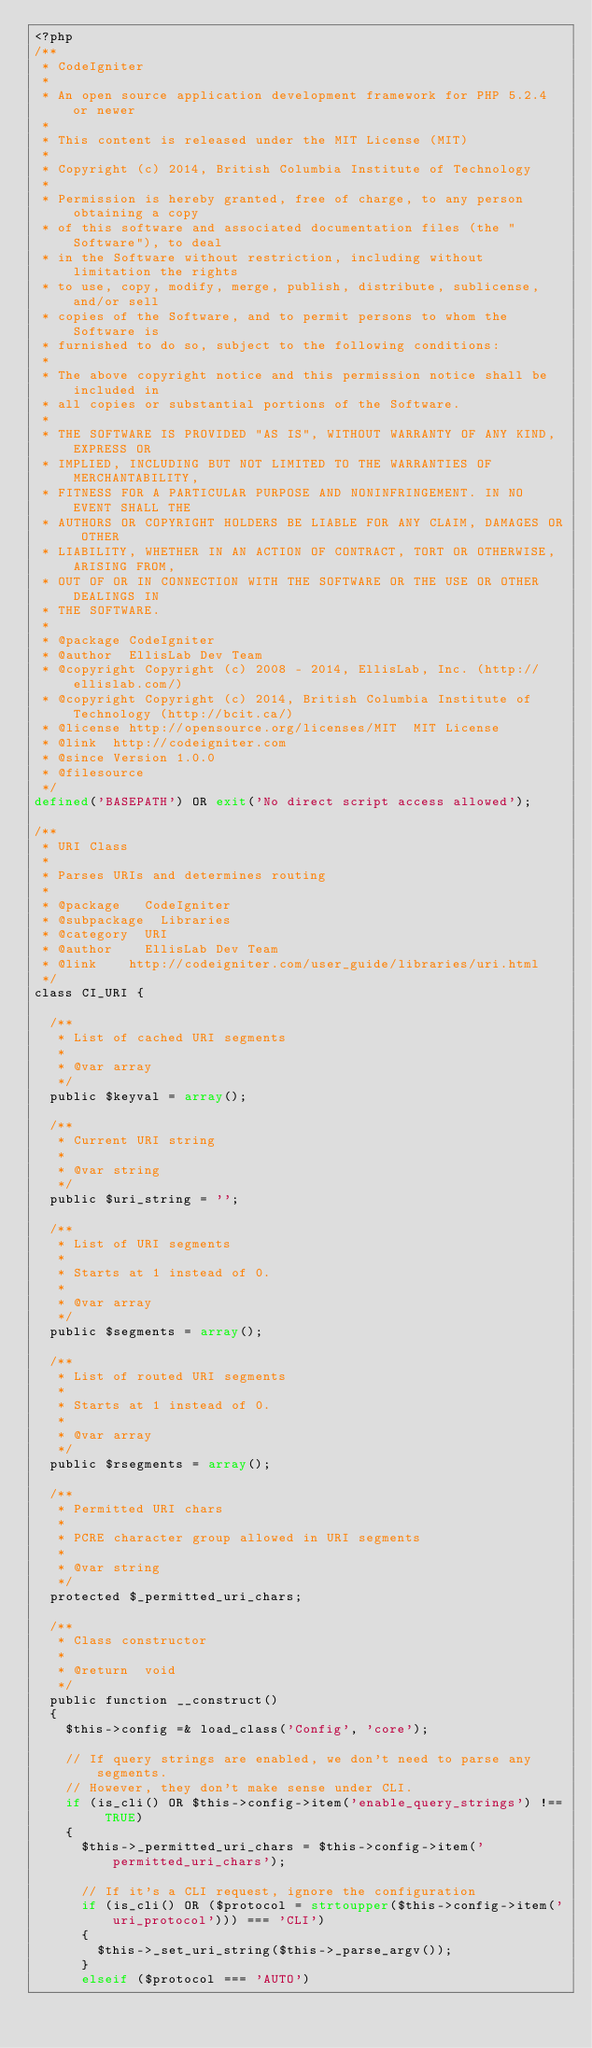<code> <loc_0><loc_0><loc_500><loc_500><_PHP_><?php
/**
 * CodeIgniter
 *
 * An open source application development framework for PHP 5.2.4 or newer
 *
 * This content is released under the MIT License (MIT)
 *
 * Copyright (c) 2014, British Columbia Institute of Technology
 *
 * Permission is hereby granted, free of charge, to any person obtaining a copy
 * of this software and associated documentation files (the "Software"), to deal
 * in the Software without restriction, including without limitation the rights
 * to use, copy, modify, merge, publish, distribute, sublicense, and/or sell
 * copies of the Software, and to permit persons to whom the Software is
 * furnished to do so, subject to the following conditions:
 *
 * The above copyright notice and this permission notice shall be included in
 * all copies or substantial portions of the Software.
 *
 * THE SOFTWARE IS PROVIDED "AS IS", WITHOUT WARRANTY OF ANY KIND, EXPRESS OR
 * IMPLIED, INCLUDING BUT NOT LIMITED TO THE WARRANTIES OF MERCHANTABILITY,
 * FITNESS FOR A PARTICULAR PURPOSE AND NONINFRINGEMENT. IN NO EVENT SHALL THE
 * AUTHORS OR COPYRIGHT HOLDERS BE LIABLE FOR ANY CLAIM, DAMAGES OR OTHER
 * LIABILITY, WHETHER IN AN ACTION OF CONTRACT, TORT OR OTHERWISE, ARISING FROM,
 * OUT OF OR IN CONNECTION WITH THE SOFTWARE OR THE USE OR OTHER DEALINGS IN
 * THE SOFTWARE.
 *
 * @package	CodeIgniter
 * @author	EllisLab Dev Team
 * @copyright	Copyright (c) 2008 - 2014, EllisLab, Inc. (http://ellislab.com/)
 * @copyright	Copyright (c) 2014, British Columbia Institute of Technology (http://bcit.ca/)
 * @license	http://opensource.org/licenses/MIT	MIT License
 * @link	http://codeigniter.com
 * @since	Version 1.0.0
 * @filesource
 */
defined('BASEPATH') OR exit('No direct script access allowed');

/**
 * URI Class
 *
 * Parses URIs and determines routing
 *
 * @package		CodeIgniter
 * @subpackage	Libraries
 * @category	URI
 * @author		EllisLab Dev Team
 * @link		http://codeigniter.com/user_guide/libraries/uri.html
 */
class CI_URI {

	/**
	 * List of cached URI segments
	 *
	 * @var	array
	 */
	public $keyval = array();

	/**
	 * Current URI string
	 *
	 * @var	string
	 */
	public $uri_string = '';

	/**
	 * List of URI segments
	 *
	 * Starts at 1 instead of 0.
	 *
	 * @var	array
	 */
	public $segments = array();

	/**
	 * List of routed URI segments
	 *
	 * Starts at 1 instead of 0.
	 *
	 * @var	array
	 */
	public $rsegments = array();

	/**
	 * Permitted URI chars
	 *
	 * PCRE character group allowed in URI segments
	 *
	 * @var	string
	 */
	protected $_permitted_uri_chars;

	/**
	 * Class constructor
	 *
	 * @return	void
	 */
	public function __construct()
	{
		$this->config =& load_class('Config', 'core');

		// If query strings are enabled, we don't need to parse any segments.
		// However, they don't make sense under CLI.
		if (is_cli() OR $this->config->item('enable_query_strings') !== TRUE)
		{
			$this->_permitted_uri_chars = $this->config->item('permitted_uri_chars');

			// If it's a CLI request, ignore the configuration
			if (is_cli() OR ($protocol = strtoupper($this->config->item('uri_protocol'))) === 'CLI')
			{
				$this->_set_uri_string($this->_parse_argv());
			}
			elseif ($protocol === 'AUTO')</code> 